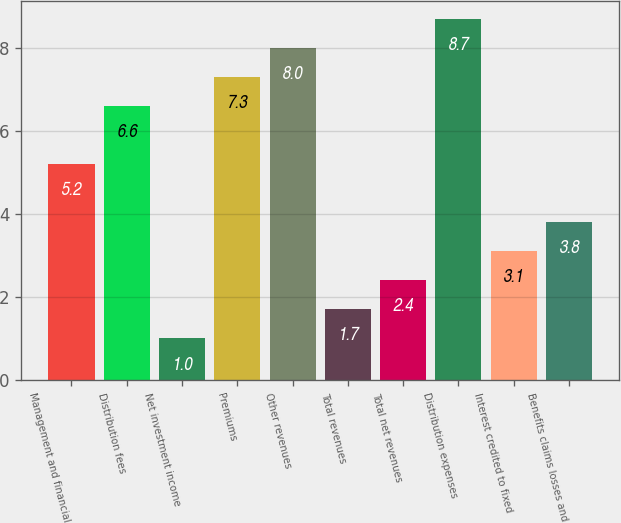Convert chart. <chart><loc_0><loc_0><loc_500><loc_500><bar_chart><fcel>Management and financial<fcel>Distribution fees<fcel>Net investment income<fcel>Premiums<fcel>Other revenues<fcel>Total revenues<fcel>Total net revenues<fcel>Distribution expenses<fcel>Interest credited to fixed<fcel>Benefits claims losses and<nl><fcel>5.2<fcel>6.6<fcel>1<fcel>7.3<fcel>8<fcel>1.7<fcel>2.4<fcel>8.7<fcel>3.1<fcel>3.8<nl></chart> 